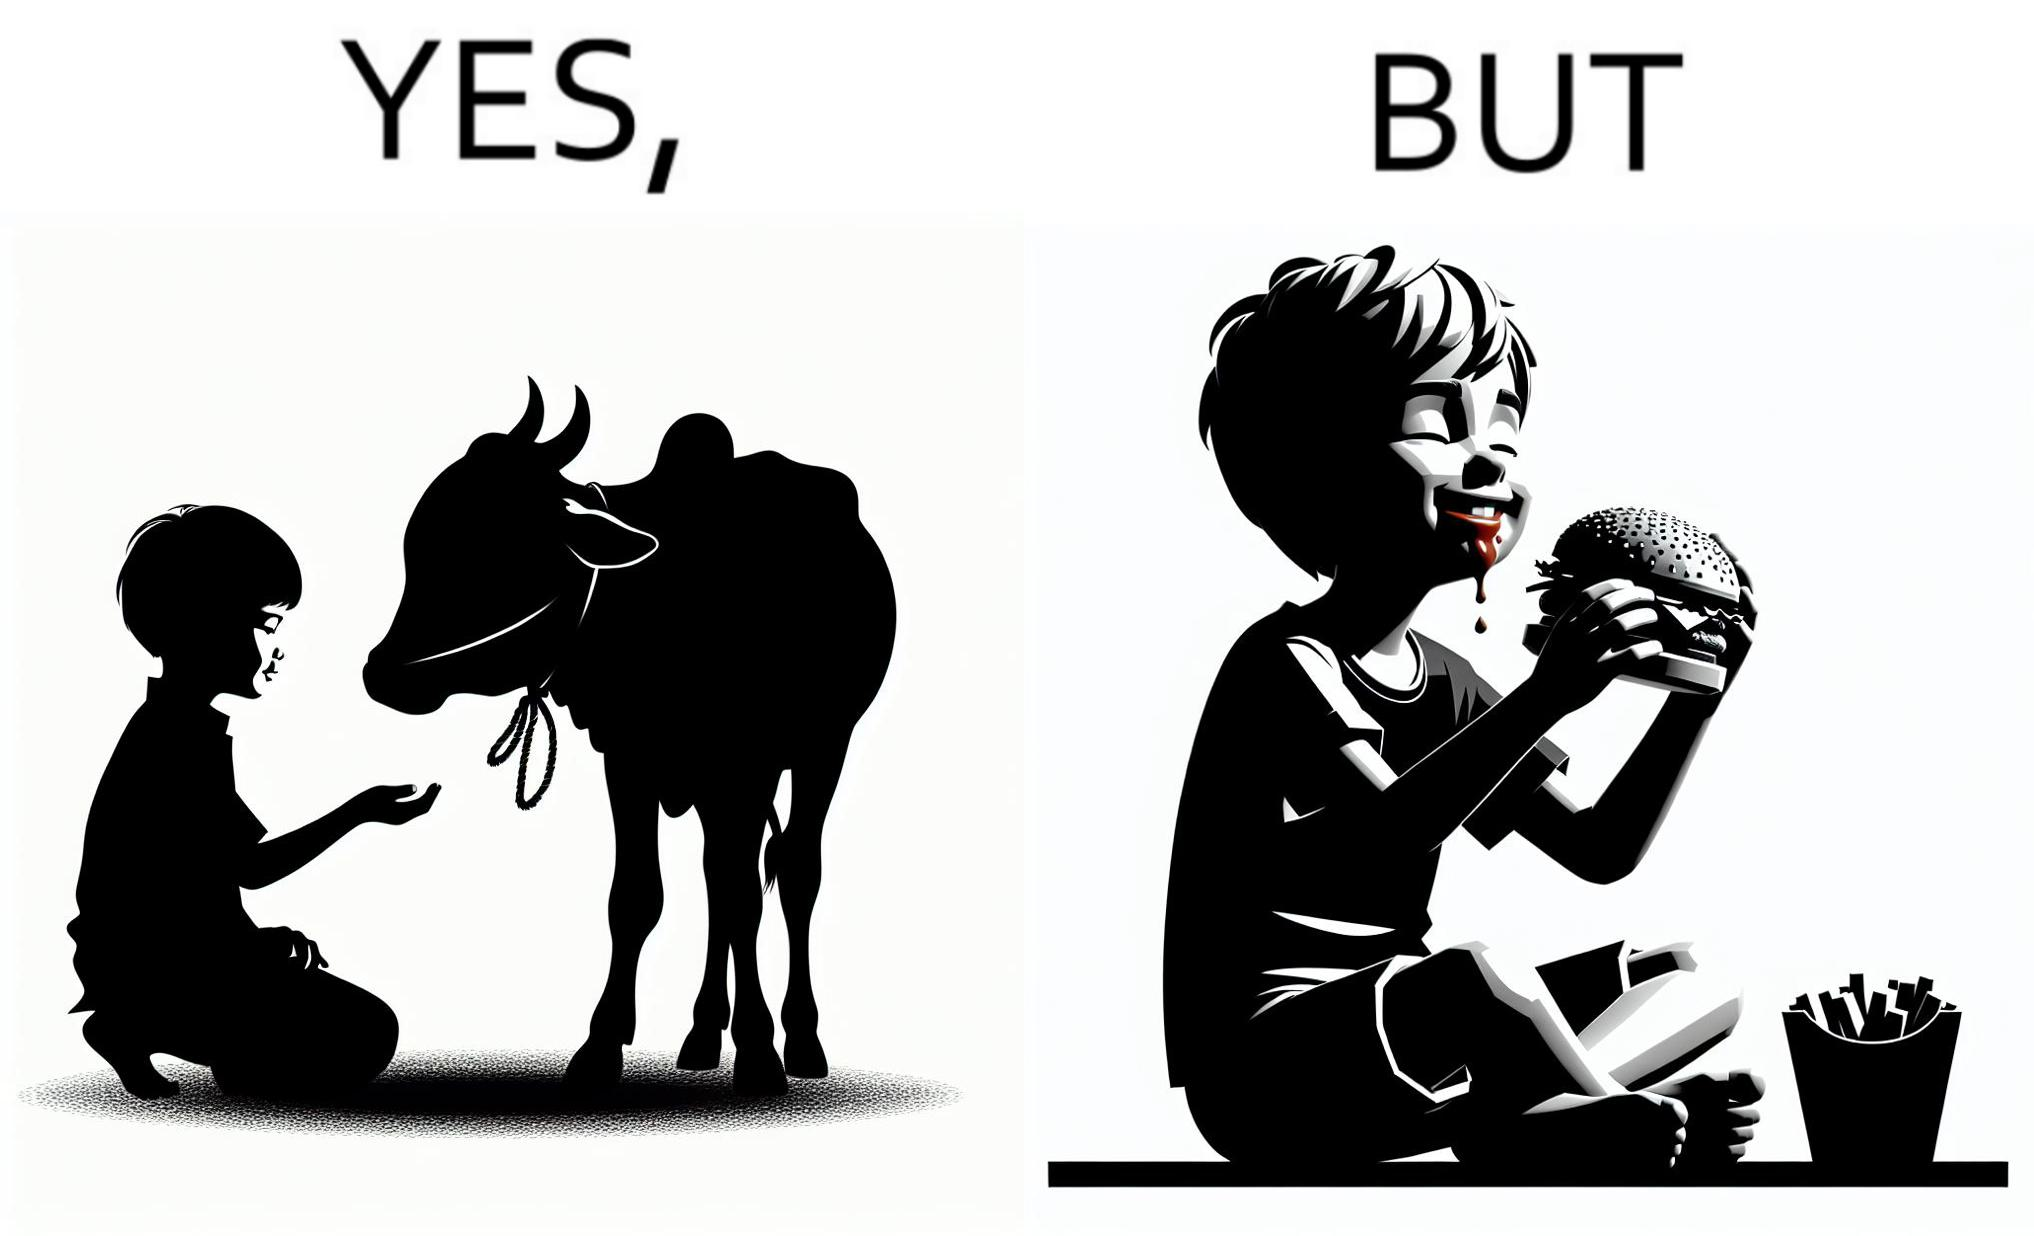Is there satirical content in this image? Yes, this image is satirical. 